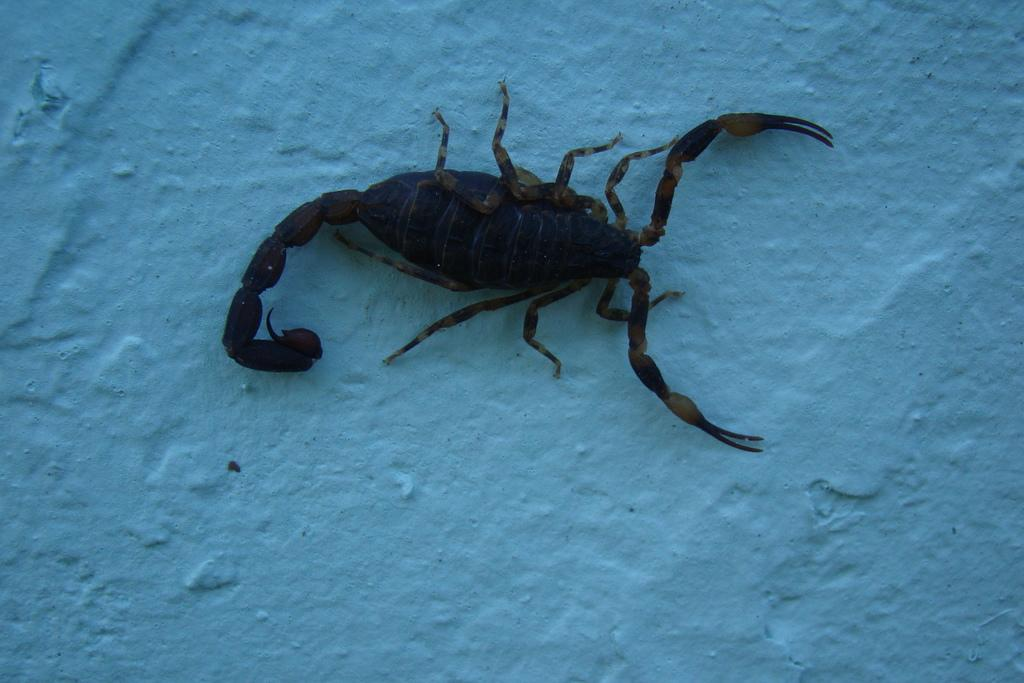What is the main subject of the image? The main subject of the image is a scorpion. Where is the scorpion located in the image? The scorpion is on a platform in the image. What color is the paint on the cave walls in the image? There is no cave or paint present in the image; it features a scorpion on a platform. 